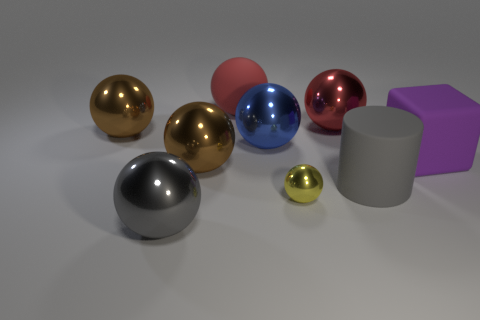Subtract 4 spheres. How many spheres are left? 3 Subtract all small yellow spheres. How many spheres are left? 6 Subtract all red spheres. How many spheres are left? 5 Subtract all cyan spheres. Subtract all cyan cylinders. How many spheres are left? 7 Add 1 red matte objects. How many objects exist? 10 Subtract all cubes. How many objects are left? 8 Add 1 yellow metal spheres. How many yellow metal spheres are left? 2 Add 2 cyan rubber cylinders. How many cyan rubber cylinders exist? 2 Subtract 0 green cubes. How many objects are left? 9 Subtract all gray matte things. Subtract all cylinders. How many objects are left? 7 